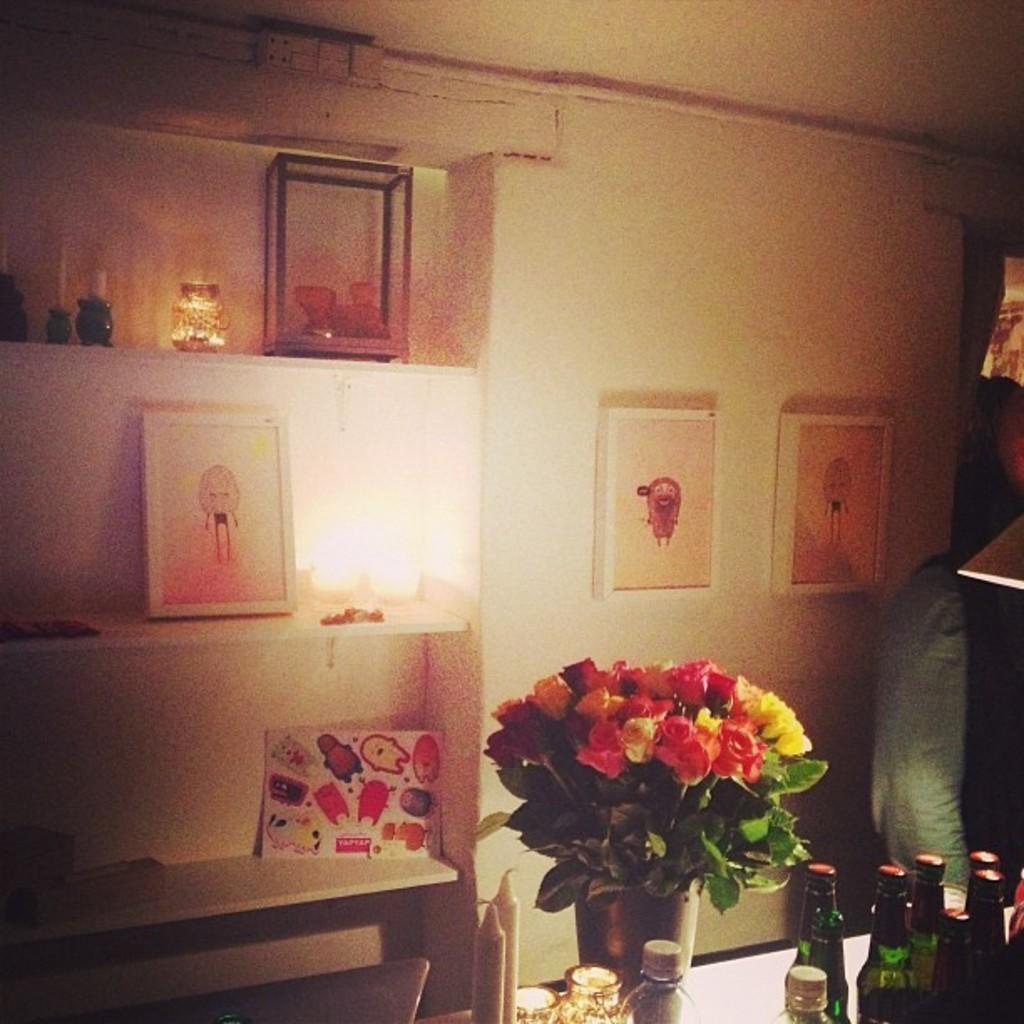Describe this image in one or two sentences. On the left side there is a cupboard with racks. On that there are photo frames, lights and many other things. Also there is a wall with photo frames. There is a table. On the table there are bottles, candles and a vase with flowers. 